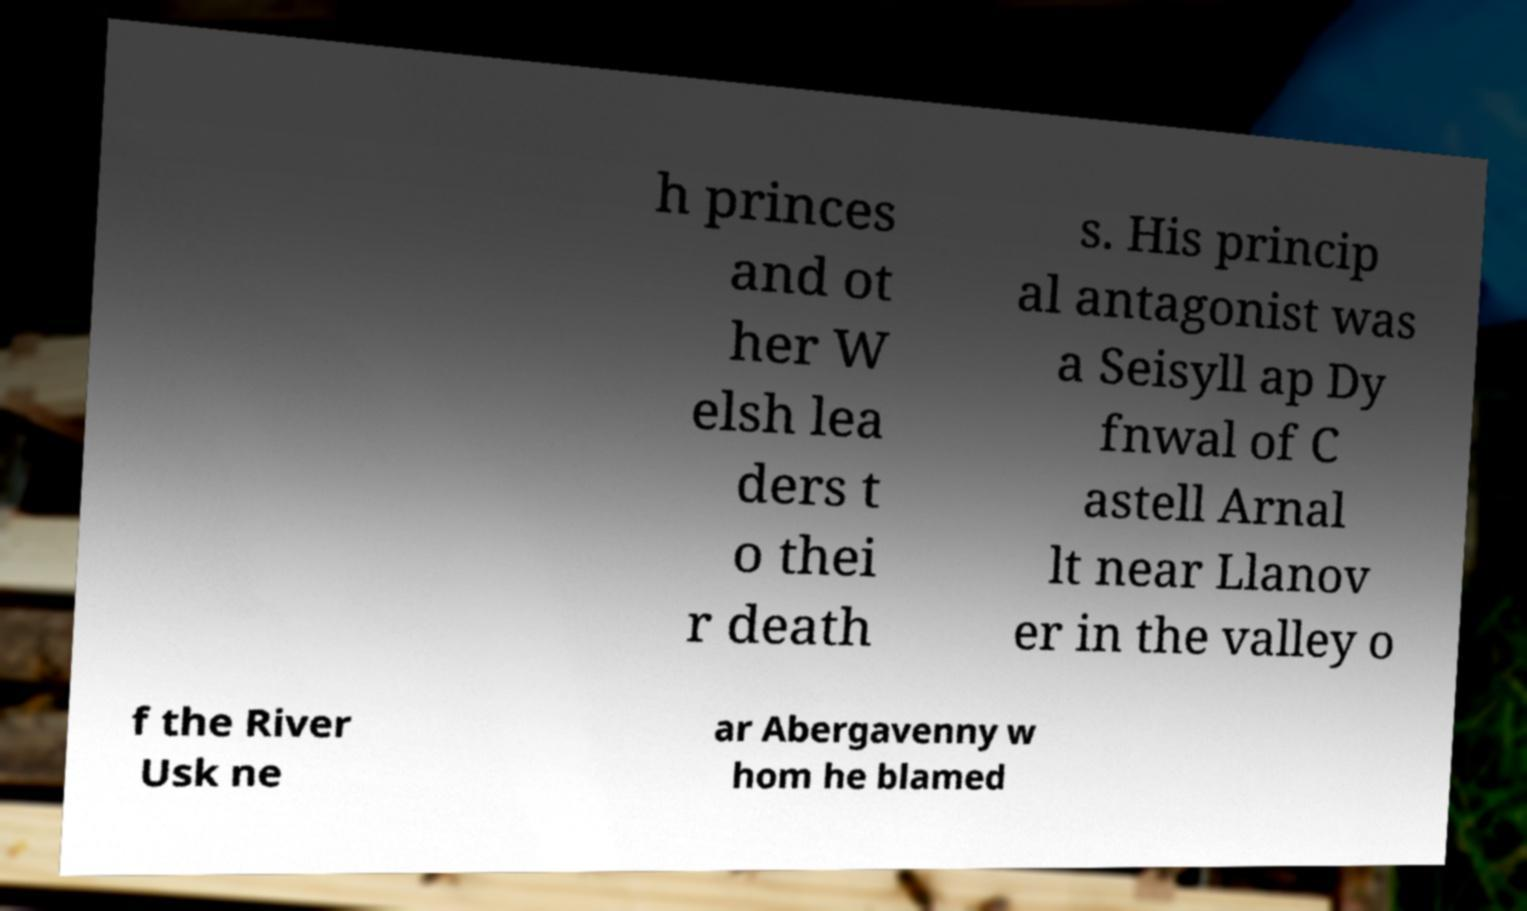There's text embedded in this image that I need extracted. Can you transcribe it verbatim? h princes and ot her W elsh lea ders t o thei r death s. His princip al antagonist was a Seisyll ap Dy fnwal of C astell Arnal lt near Llanov er in the valley o f the River Usk ne ar Abergavenny w hom he blamed 